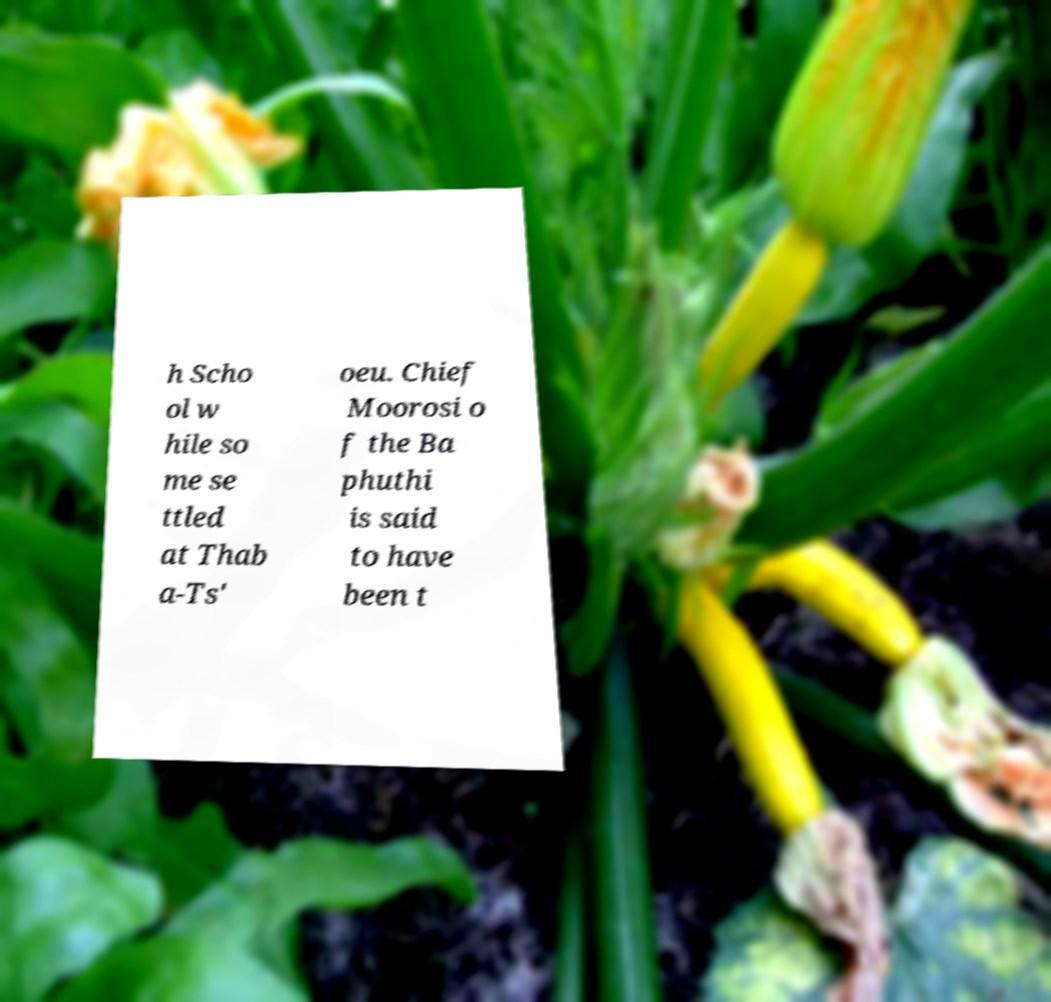I need the written content from this picture converted into text. Can you do that? h Scho ol w hile so me se ttled at Thab a-Ts' oeu. Chief Moorosi o f the Ba phuthi is said to have been t 